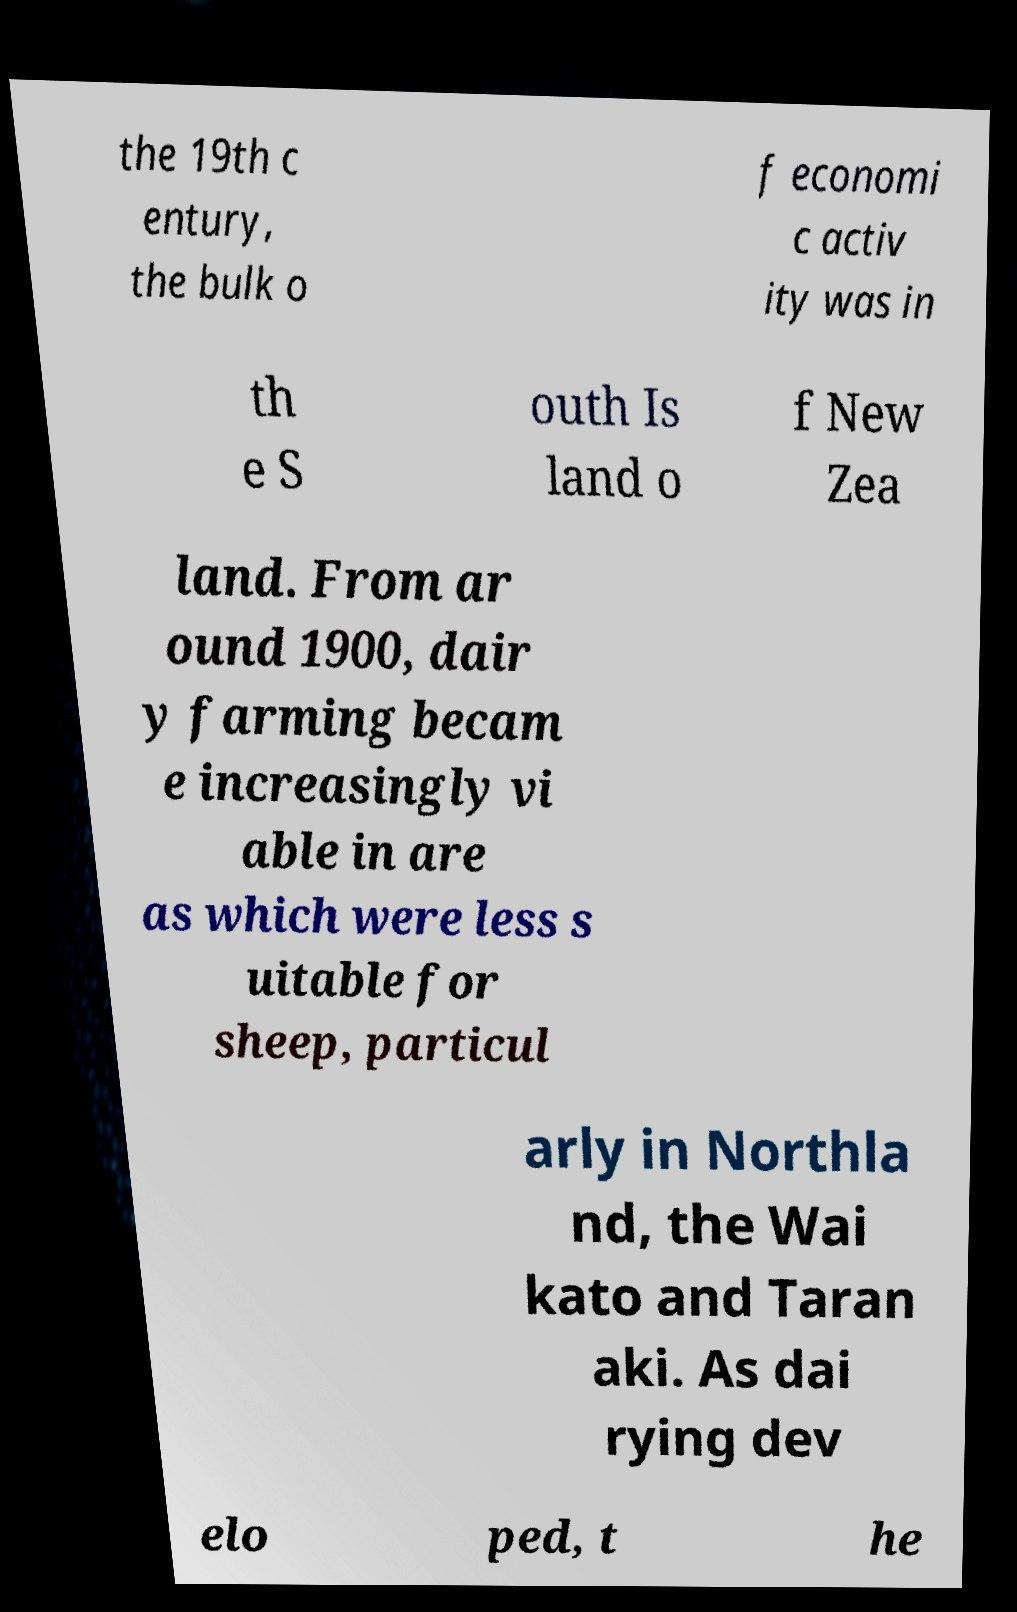Please identify and transcribe the text found in this image. the 19th c entury, the bulk o f economi c activ ity was in th e S outh Is land o f New Zea land. From ar ound 1900, dair y farming becam e increasingly vi able in are as which were less s uitable for sheep, particul arly in Northla nd, the Wai kato and Taran aki. As dai rying dev elo ped, t he 